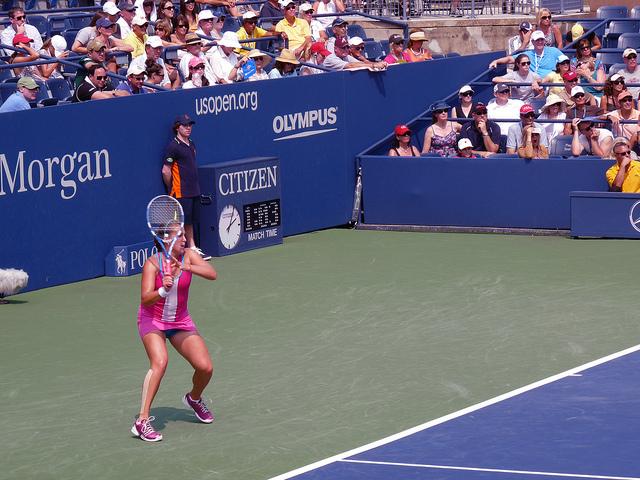With which hand is the tennis player holding the racket?
Keep it brief. Right. At what time was this picture taken?
Give a very brief answer. 1:03. What two colors are on the sign?
Give a very brief answer. Blue and white. What is the overall color of the player's attire?
Concise answer only. Pink. What color is her dress?
Be succinct. Pink. Is this person serving?
Give a very brief answer. No. Who is playing?
Write a very short answer. Woman. 